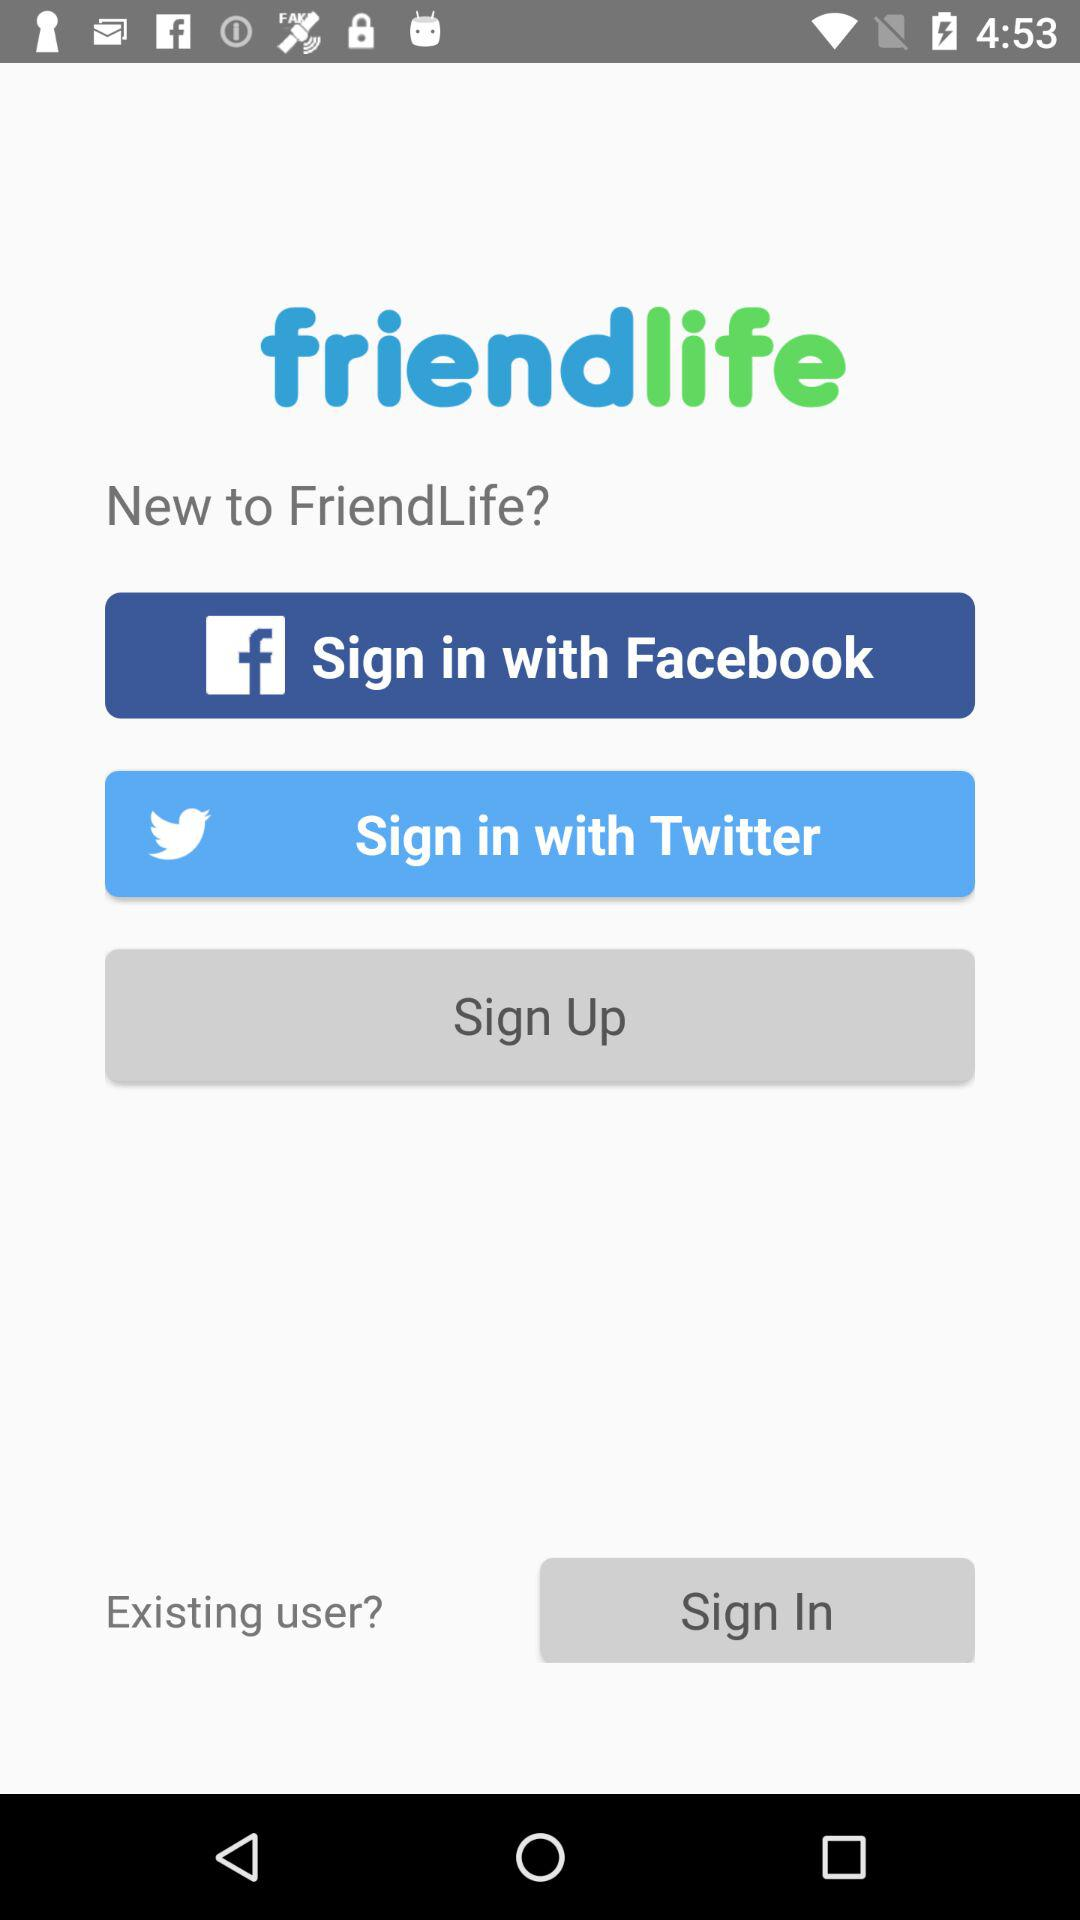How many sign in options are there?
Answer the question using a single word or phrase. 3 